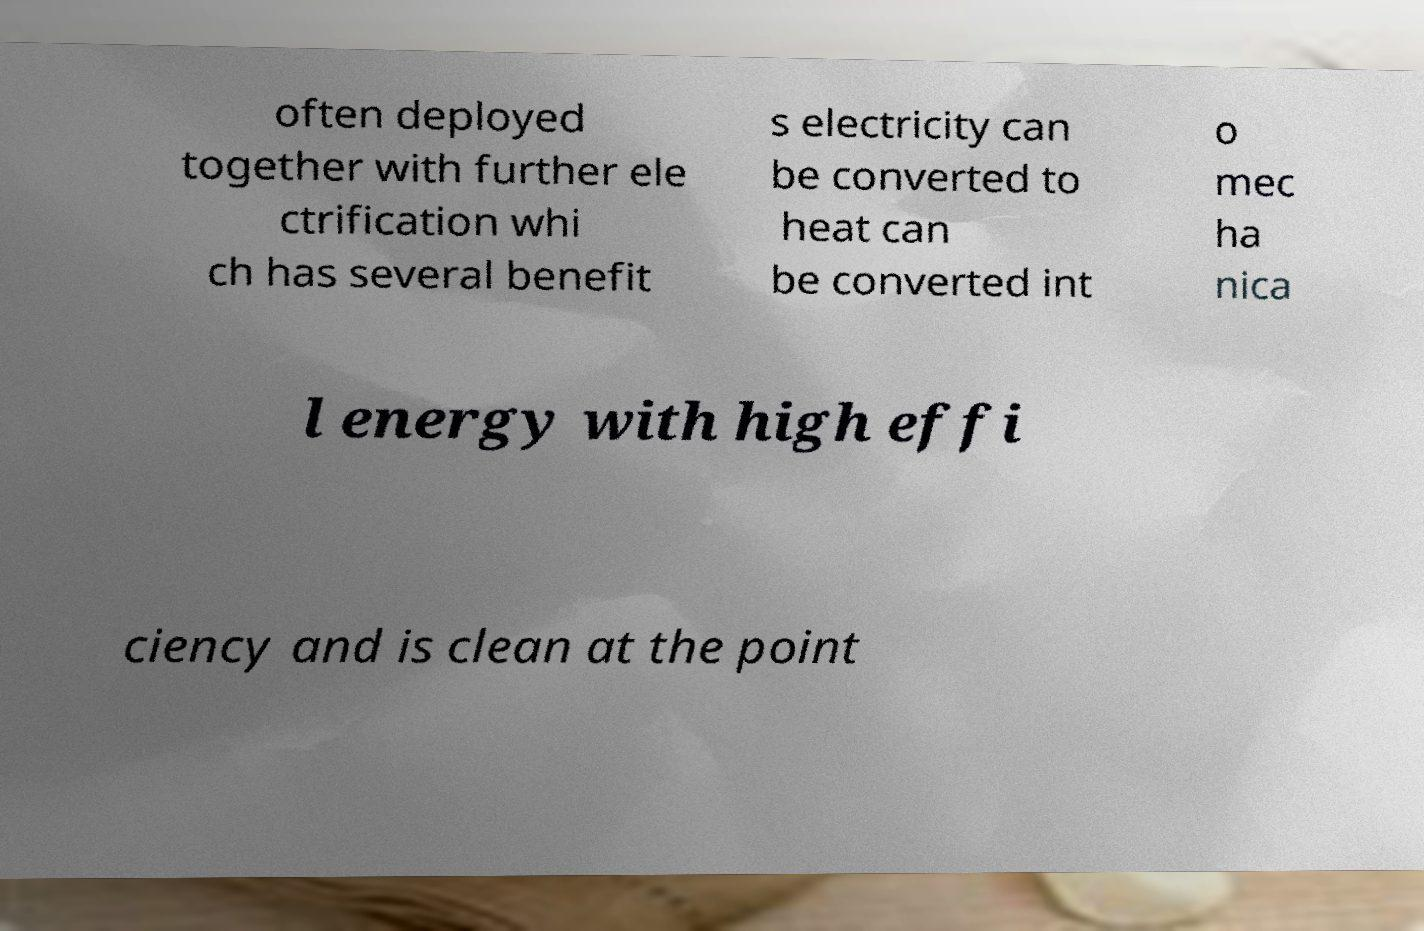Can you read and provide the text displayed in the image?This photo seems to have some interesting text. Can you extract and type it out for me? often deployed together with further ele ctrification whi ch has several benefit s electricity can be converted to heat can be converted int o mec ha nica l energy with high effi ciency and is clean at the point 